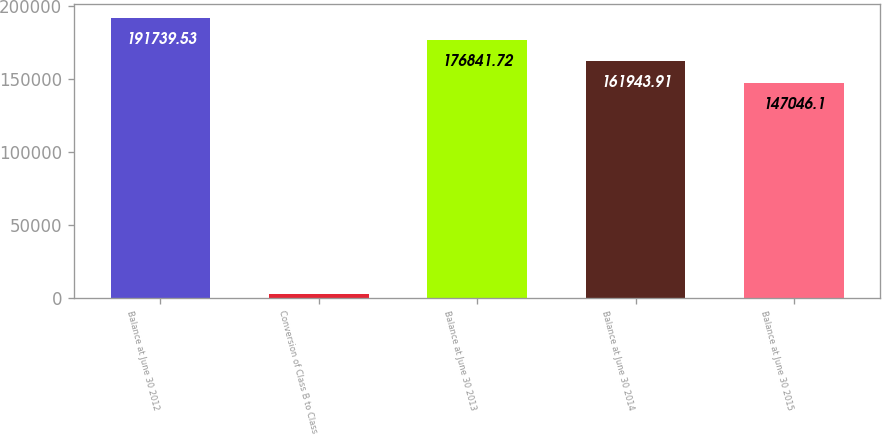Convert chart. <chart><loc_0><loc_0><loc_500><loc_500><bar_chart><fcel>Balance at June 30 2012<fcel>Conversion of Class B to Class<fcel>Balance at June 30 2013<fcel>Balance at June 30 2014<fcel>Balance at June 30 2015<nl><fcel>191740<fcel>2800<fcel>176842<fcel>161944<fcel>147046<nl></chart> 